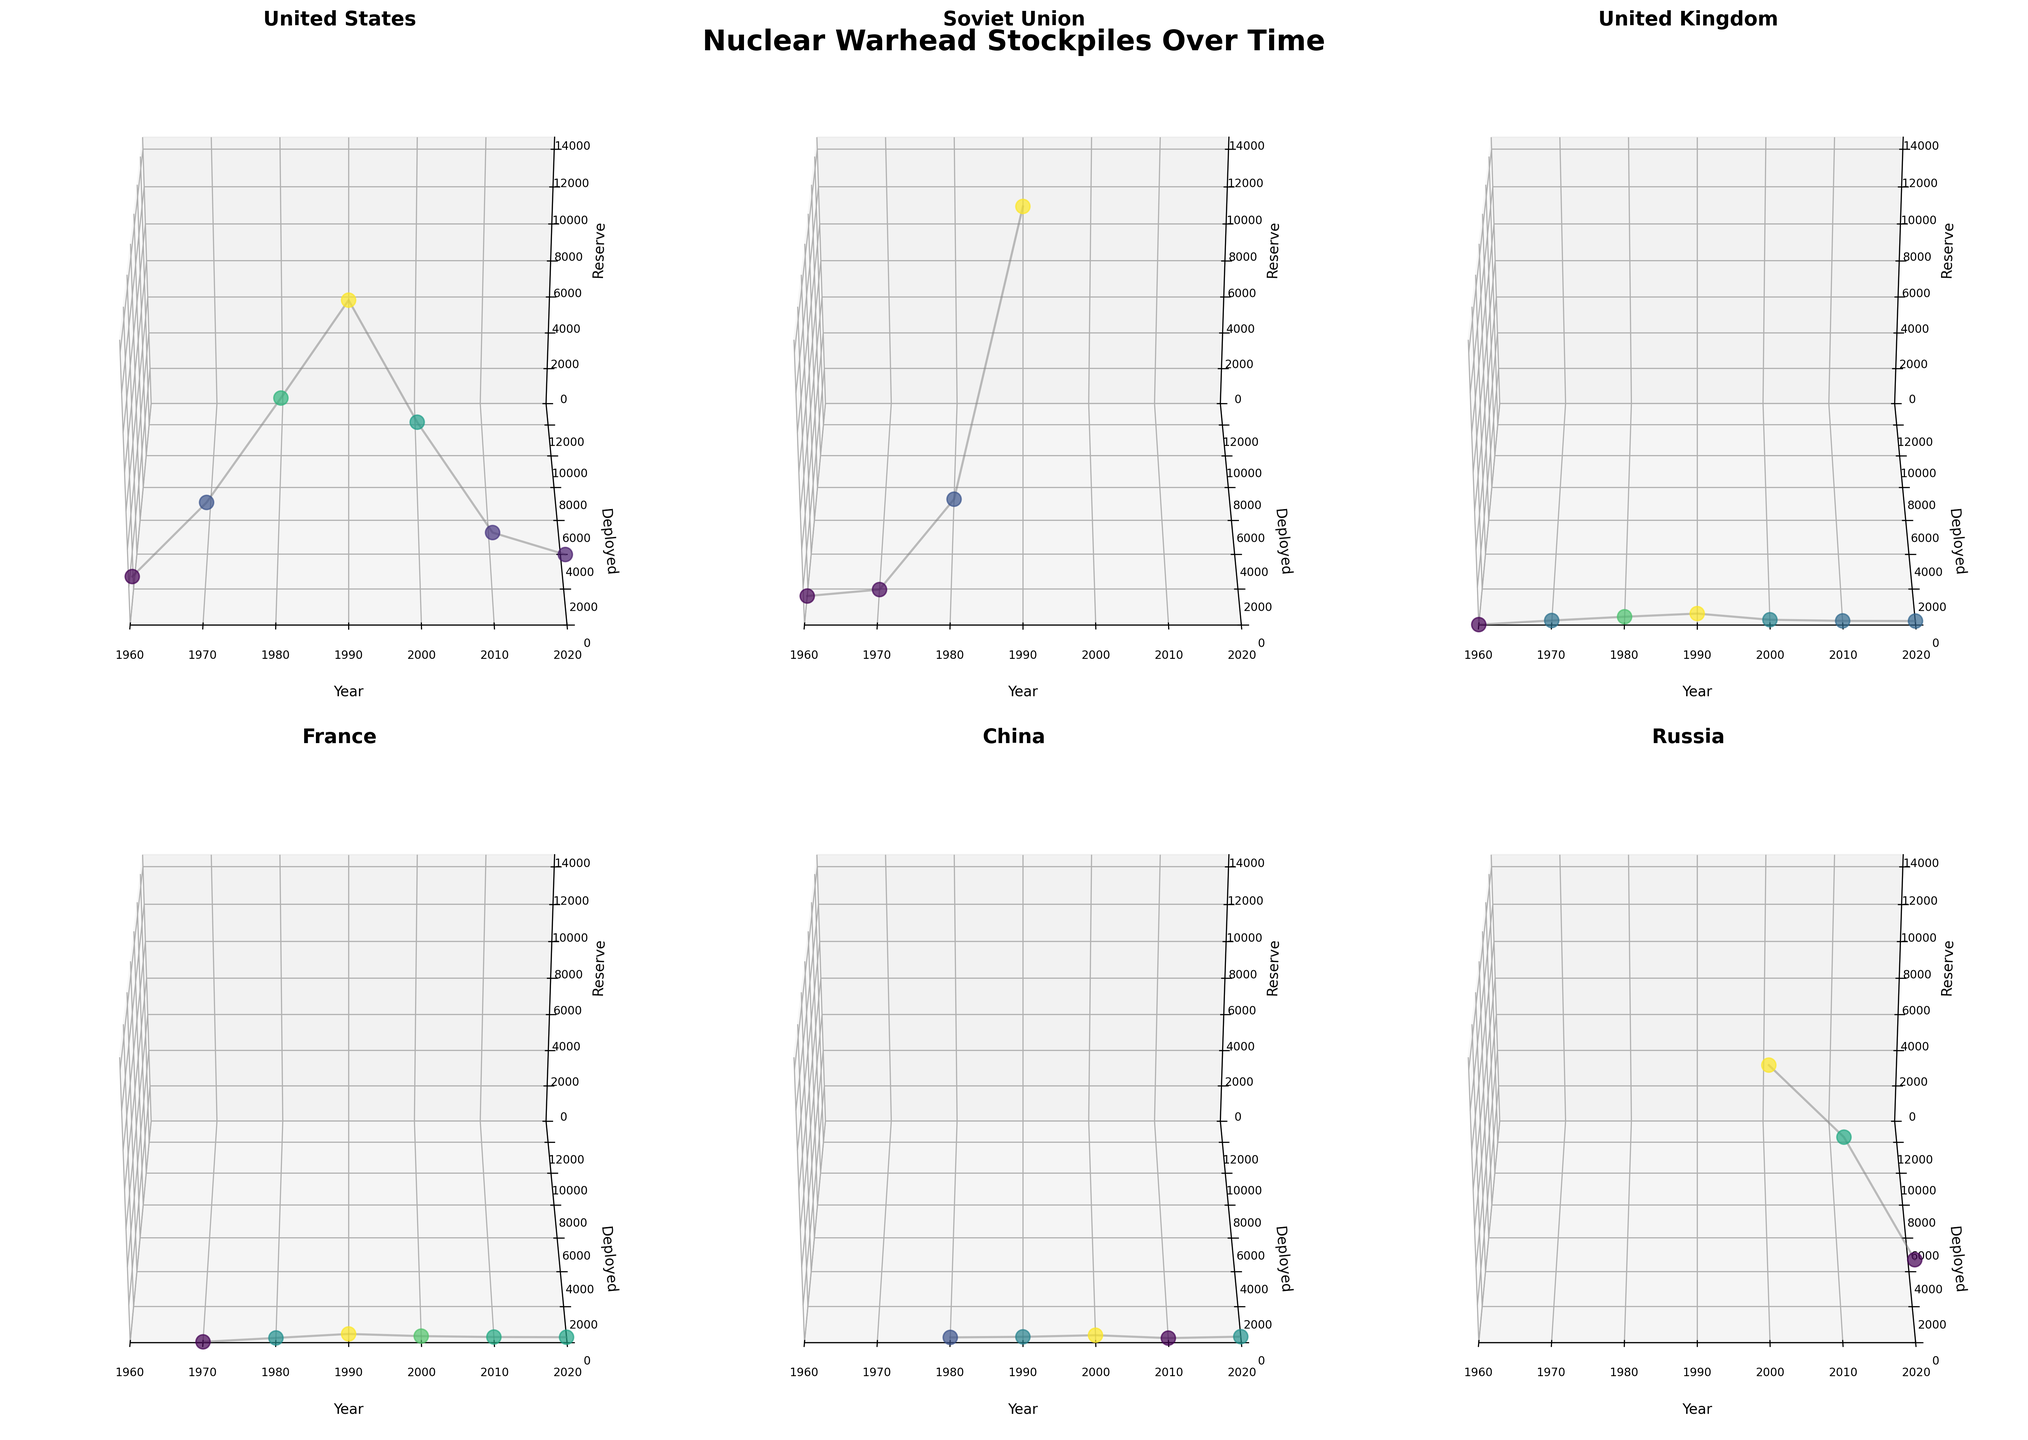What's the trend over time for the United States' deployed nuclear warheads? The subplot for the United States shows the `x-axis` representing the year and the `y-axis` representing the number of deployed nuclear warheads. By following the data points and connected lines, we can observe the trend. The trend shows an initial increase, peaking around 1990, followed by a significant decline towards 2020.
Answer: Increase until around 1990, then decline In which year did Russia have the highest number of reserve nuclear warheads? To find the year where Russia had the highest number of reserve nuclear warheads, look at the `z-axis` values for Russia across different years. The highest point in the `z-axis` corresponding to the reserve warheads value indicates the year. From the plot, this appears to be around 1990.
Answer: 1990 Compare the trend of the deployed nuclear warheads between China and France. Which country shows more variability over the years? Observe the subplots for both China and France. Follow the changes along the `y-axis` (deployed warheads) over time (`x-axis`). China's deployed warheads data points are relatively flat with minor variations, while France's data points show more fluctuations. Hence, France exhibits more variability.
Answer: France Did the United Kingdom ever have more than 500 combined deployed and reserve warheads? For this, sum the `y` and `z` values (deployed and reserve) for each year in the United Kingdom's subplot. If any year's total exceeds 500, the answer is yes. The combined values never exceed 500.
Answer: No During which decades did the United States show a significant reduction in its reserve nuclear warheads? Inspect the `z-axis` (reserve warheads) values for the United States subplot through each decade. A noticeable decline in the `z-axis` values marks significant reduction periods. The decades showing a reduction are 1990-2000 and 2010-2020.
Answer: 1990-2000 and 2010-2020 Which country had the highest number of deployed nuclear warheads in 1980? Look specifically at the `y-axis` (deployed warheads) values for 1980 in each subplot. The highest `y` value corresponds to the country with the most deployed warheads. The United States has the highest number in 1980.
Answer: United States What is the approximate difference in the number of reserve nuclear warheads between 2000 and 2020 for Russia? Compare the `z-axis` (reserve) values for Russia in 2000 and 2020. Subtract the 2020 value from the 2000 value. From the plot, the values are approximately 9421 (2000) and 2870 (2020). The difference is 9421 - 2870 = 6551.
Answer: 6551 Based on the plot, how did China's reserve nuclear warheads change from 1980 onwards? Inspect China's subplot from 1980 onwards along the `z-axis` (reserve warheads). There are no reserve warheads until 2010, after which there is a slight increase visible in the plot.
Answer: Slight increase after 2010 Did France ever retire any nuclear warheads according to the plot? Look at the `z` label (reserve values) and additional context within the subplots to identify retired warheads. France's subplot shows the `z-axis` values remaining overall consistent and the retired category empty (values remain zero), indicating no retirement.
Answer: No Which country had the most consistent trend in deployed warheads throughout the given years? Consistent trends will have fewer fluctuations in their `y-axis` (deployed warheads) values over time (`x-axis`). The country with the least fluctuation in its subplot is China, showing a rather steady trend.
Answer: China 